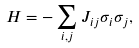Convert formula to latex. <formula><loc_0><loc_0><loc_500><loc_500>H = - \sum _ { i , j } J _ { i j } \sigma _ { i } \sigma _ { j } ,</formula> 